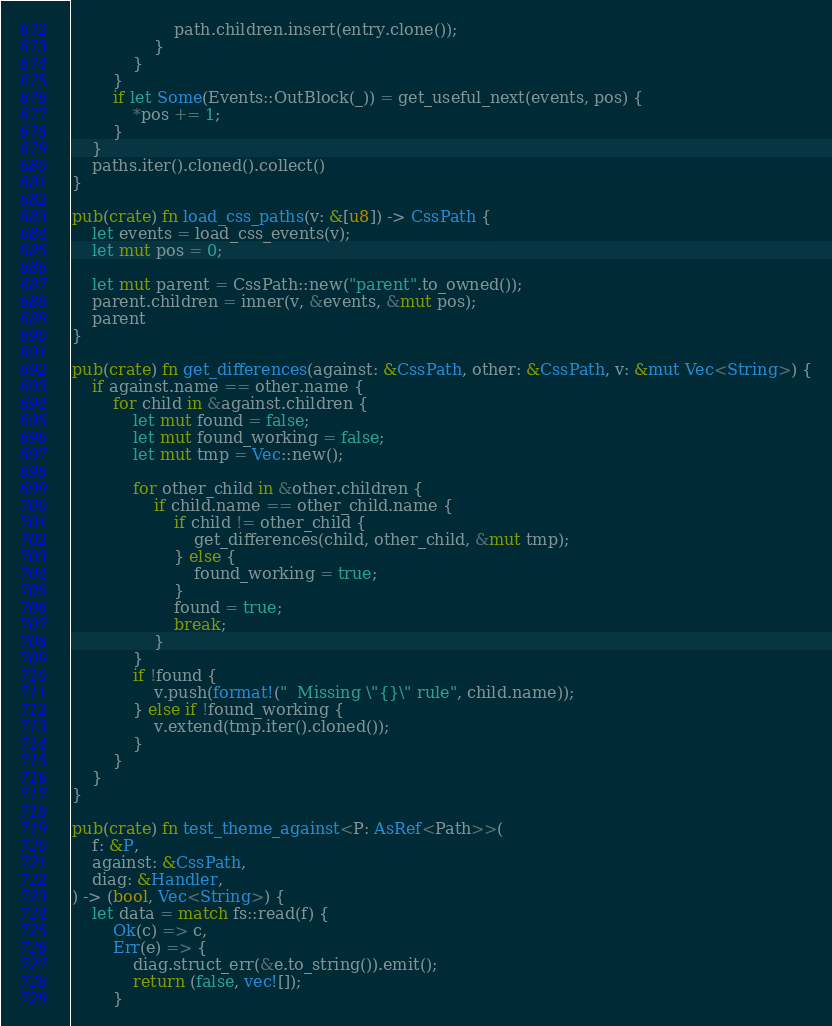<code> <loc_0><loc_0><loc_500><loc_500><_Rust_>                    path.children.insert(entry.clone());
                }
            }
        }
        if let Some(Events::OutBlock(_)) = get_useful_next(events, pos) {
            *pos += 1;
        }
    }
    paths.iter().cloned().collect()
}

pub(crate) fn load_css_paths(v: &[u8]) -> CssPath {
    let events = load_css_events(v);
    let mut pos = 0;

    let mut parent = CssPath::new("parent".to_owned());
    parent.children = inner(v, &events, &mut pos);
    parent
}

pub(crate) fn get_differences(against: &CssPath, other: &CssPath, v: &mut Vec<String>) {
    if against.name == other.name {
        for child in &against.children {
            let mut found = false;
            let mut found_working = false;
            let mut tmp = Vec::new();

            for other_child in &other.children {
                if child.name == other_child.name {
                    if child != other_child {
                        get_differences(child, other_child, &mut tmp);
                    } else {
                        found_working = true;
                    }
                    found = true;
                    break;
                }
            }
            if !found {
                v.push(format!("  Missing \"{}\" rule", child.name));
            } else if !found_working {
                v.extend(tmp.iter().cloned());
            }
        }
    }
}

pub(crate) fn test_theme_against<P: AsRef<Path>>(
    f: &P,
    against: &CssPath,
    diag: &Handler,
) -> (bool, Vec<String>) {
    let data = match fs::read(f) {
        Ok(c) => c,
        Err(e) => {
            diag.struct_err(&e.to_string()).emit();
            return (false, vec![]);
        }</code> 